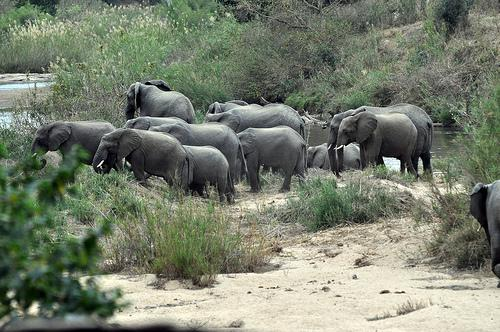Describe the landscape around the elephants using the given information. The landscape around the elephants includes grass, sand, a watering hole, tall grass growing near the water, and dried sticks and plants on the ground. Write a sentence describing the scene in the image focusing on the elephants' body parts. The elephants in the field have various visible body parts, such as tusks, trunks, tails, ears, and legs, which are all captured in the image. How many total leg image are there for the elephants in the image? There are 13 leg image for the elephants in the image. What is the main focus of this image according to the given information? The main focus of this image is a group of elephants in a field. Can you identify the sentiment of the image based on the given information? The image's sentiment is likely to be calm and peaceful, as it shows a group of elephants in a natural environment with calm water and serene surroundings. Identify attributes of the elephants. trunk, ears, tusks, legs Notice the elaborate bird's nest at the top of the tree in the background at X:220 Y:20 with a width of 10 and a height of 10. The instruction is misleading because it includes a bird's nest as an object in the image that doesn't exist. The adjective "elaborate" further piques curiosity and draws attention to this non-existent object. Describe the overall quality of the image. The image is clear and well-composed, with a natural setting and a good balance of colors. List down the emotions present in the image. calm, peace, togetherness Identify the content and relationship between the objects in the image. A herd of elephants stands together in a field of grass, near calm waters and sandy ground, with bushes in the foreground. Try to spot the hidden zebra among the elephants at X:150 Y:150 with a width of 20 and a height of 20. This instruction is misleading because it implies the existence of a zebra within the elephants that isn't actually there. The use of "hidden" and "among the elephants" adds a sense of mystery and challenge. Are there any signs of human activity in the image? No signs of human activity are found. What is the location of the tusk that is made of ivory? X:90 Y:148 Width:48 Height:48 The colorful parrot resting on the elephant's back at X:290 Y:90 with a width of 15 and a height of 15 adds a splash of vibrancy to the scene. This instruction falsely assumes the existence of a colorful parrot within the scene, which does not exist. The use of "colorful" and "vibrancy" creates an imagined focal point that is misleading. Where are the pebbles on the ground in the photo? X:257 Y:272 Width:105 Height:105 How many legs of elephants are visible in the image? 12 What is the vegetation visible in the picture? grass, bushes, tall grass, dried sticks, and plants Identify the main objects interacting in the picture. elephants, grass, water, and sand Locate a watering hole in the image. X:298 Y:112 Width:200 Height:200 Detect if there is any unusual element in this image. No unusual elements detected. State the position of the head of an elephant. X:76 Y:123 Width:60 Height:60 Count the number of elephants in the image. 9 What is the main subject of the image? A herd of elephants in the field. Segment and mention the different areas of the image. elephants, grass, water, sand, bushes Determine if the herd of elephants is large or small. The herd of elephants is relatively large. Does the text in the image contain any relevant information? No text found in the image. Isn't it interesting how the lion is perched peacefully on a tree branch at X:400 Y:70 with a width of 30 and a height of 30? This instruction uses an interrogative sentence to imply the existence of a lion in the image that isn't there. The use of "interesting" and "peacefully" enhances the misleading effect, as people might be eager to find the scene. Can you see the family of monkeys playing near the water at X:450 Y:200 with a width of 50 and a height of 50? This misleading instruction uses an interrogative sentence and the family-oriented imagery of a "family of monkeys playing" to create a false setting. The location coordinate indicates an event happening near the water that does not exist. Did you notice the snake slowly slithering on the grass near the elephant's foot at X:80 Y:140 with a width of 12 and a height of 12? This instruction is misleading as it uses an interrogative sentence to bring attention to a non-existent snake. The "slowly slithering" action and proximity to the "elephant's foot" adds tension and intrigue, further captivating the reader's imagination. 